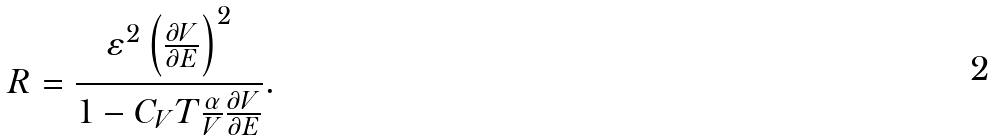<formula> <loc_0><loc_0><loc_500><loc_500>R = \frac { \varepsilon ^ { 2 } \left ( \frac { \partial V } { \partial E } \right ) ^ { 2 } } { 1 - C _ { V } T \frac { \alpha } { V } \frac { \partial V } { \partial E } } .</formula> 